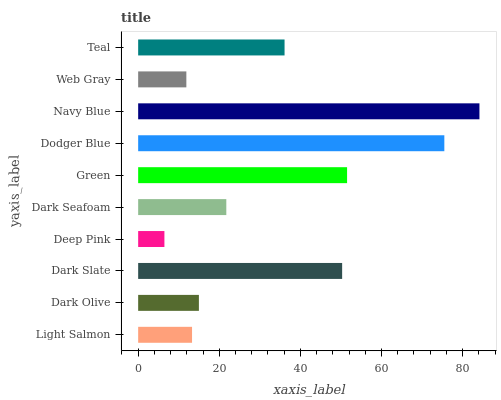Is Deep Pink the minimum?
Answer yes or no. Yes. Is Navy Blue the maximum?
Answer yes or no. Yes. Is Dark Olive the minimum?
Answer yes or no. No. Is Dark Olive the maximum?
Answer yes or no. No. Is Dark Olive greater than Light Salmon?
Answer yes or no. Yes. Is Light Salmon less than Dark Olive?
Answer yes or no. Yes. Is Light Salmon greater than Dark Olive?
Answer yes or no. No. Is Dark Olive less than Light Salmon?
Answer yes or no. No. Is Teal the high median?
Answer yes or no. Yes. Is Dark Seafoam the low median?
Answer yes or no. Yes. Is Dodger Blue the high median?
Answer yes or no. No. Is Dark Olive the low median?
Answer yes or no. No. 